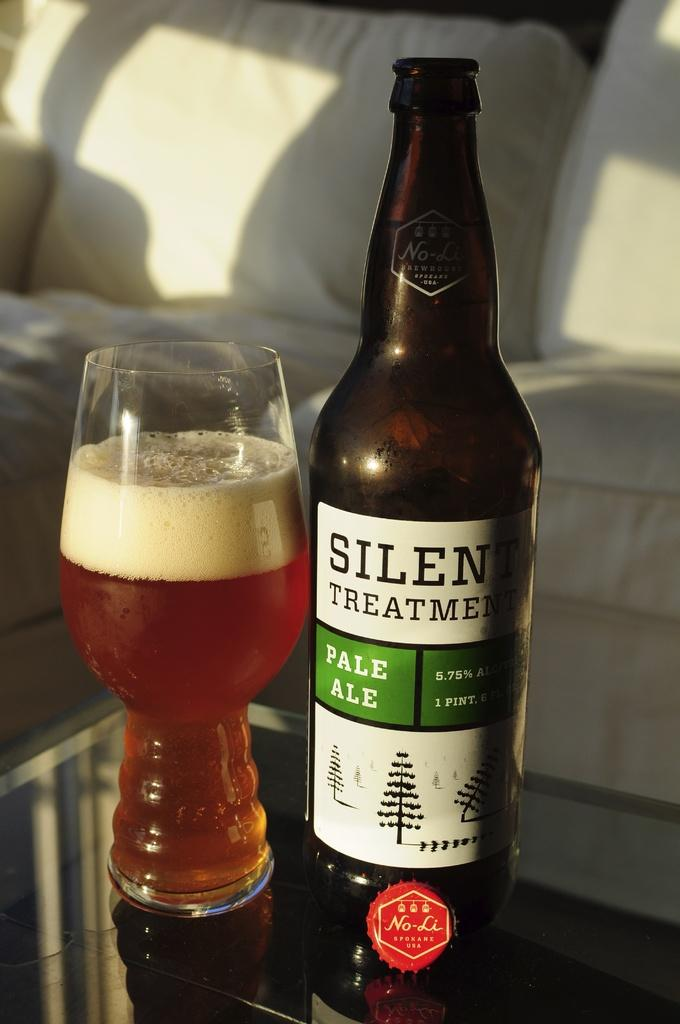<image>
Offer a succinct explanation of the picture presented. a silent treatment pale ale and a glass with it poured out 